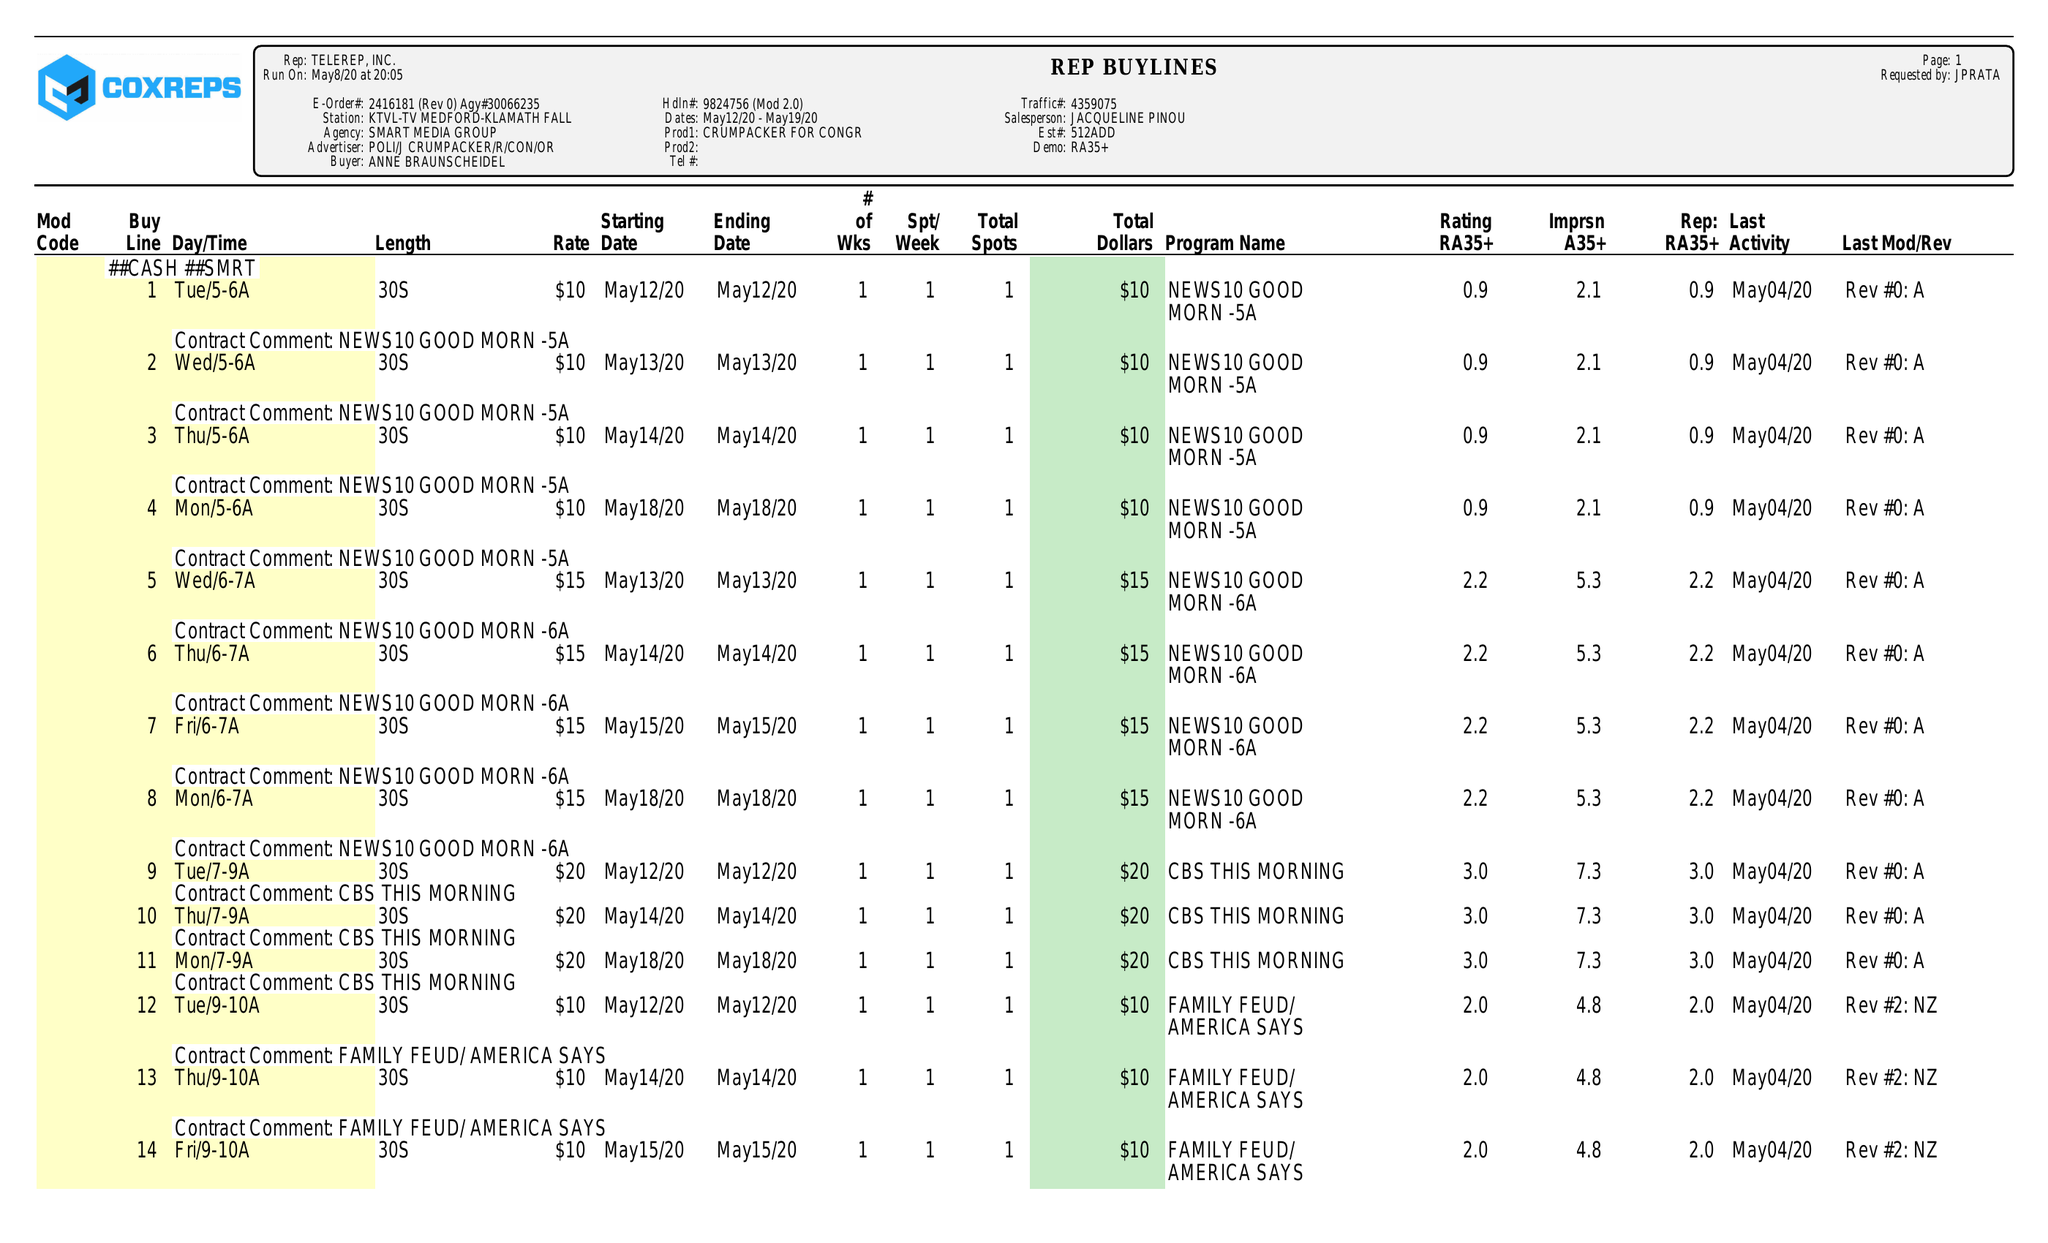What is the value for the flight_from?
Answer the question using a single word or phrase. 05/12/20 